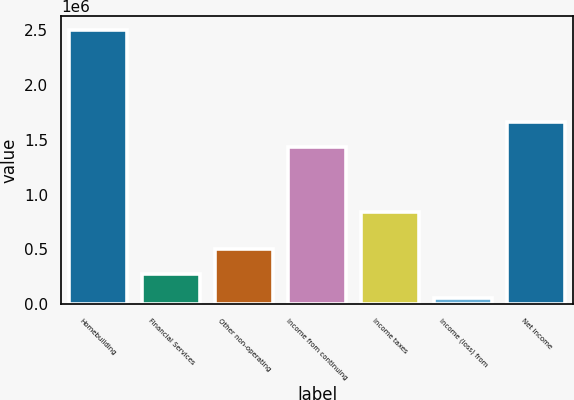Convert chart to OTSL. <chart><loc_0><loc_0><loc_500><loc_500><bar_chart><fcel>Homebuilding<fcel>Financial Services<fcel>Other non-operating<fcel>Income from continuing<fcel>Income taxes<fcel>Income (loss) from<fcel>Net income<nl><fcel>2.50139e+06<fcel>279405<fcel>503784<fcel>1.43689e+06<fcel>840126<fcel>55025<fcel>1.66127e+06<nl></chart> 